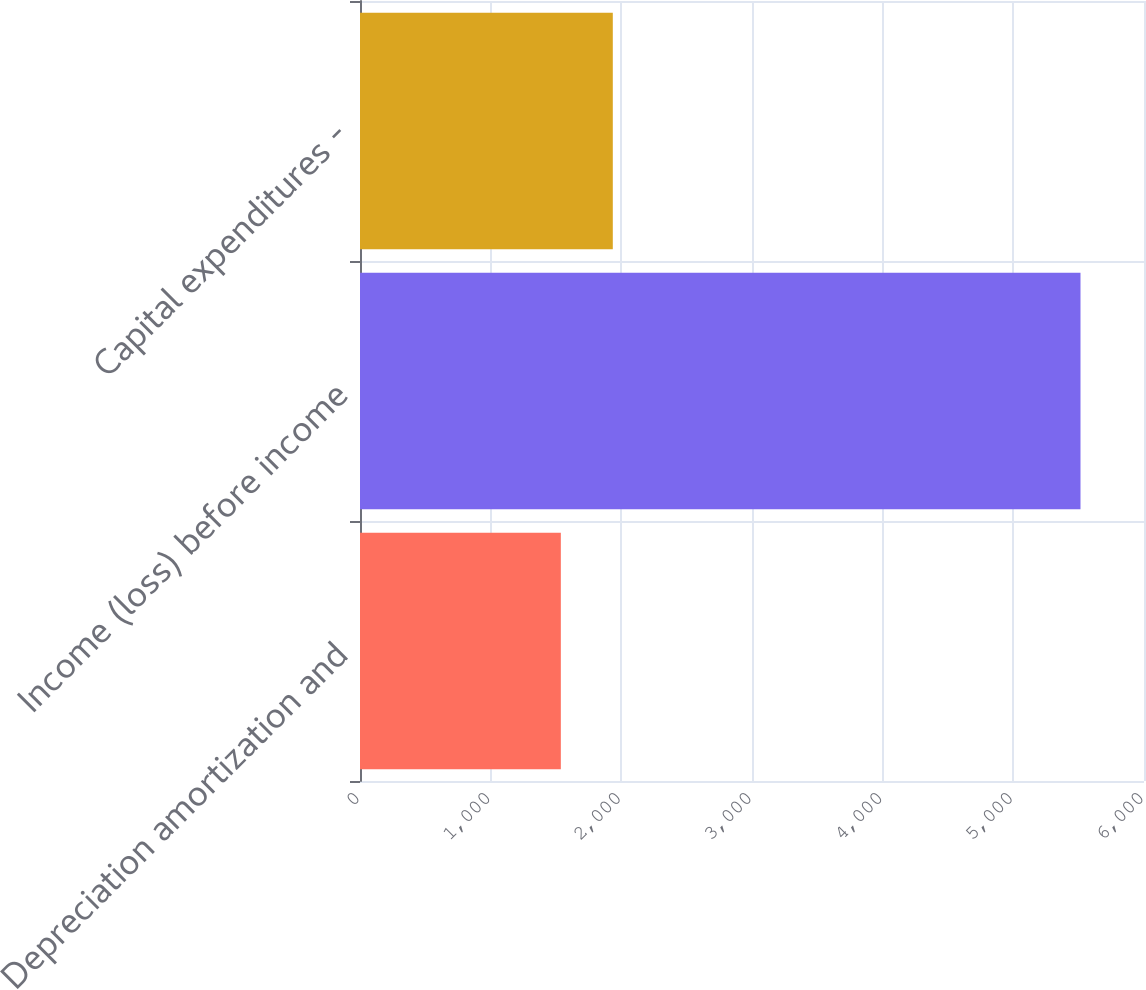Convert chart. <chart><loc_0><loc_0><loc_500><loc_500><bar_chart><fcel>Depreciation amortization and<fcel>Income (loss) before income<fcel>Capital expenditures -<nl><fcel>1537<fcel>5514<fcel>1934.7<nl></chart> 